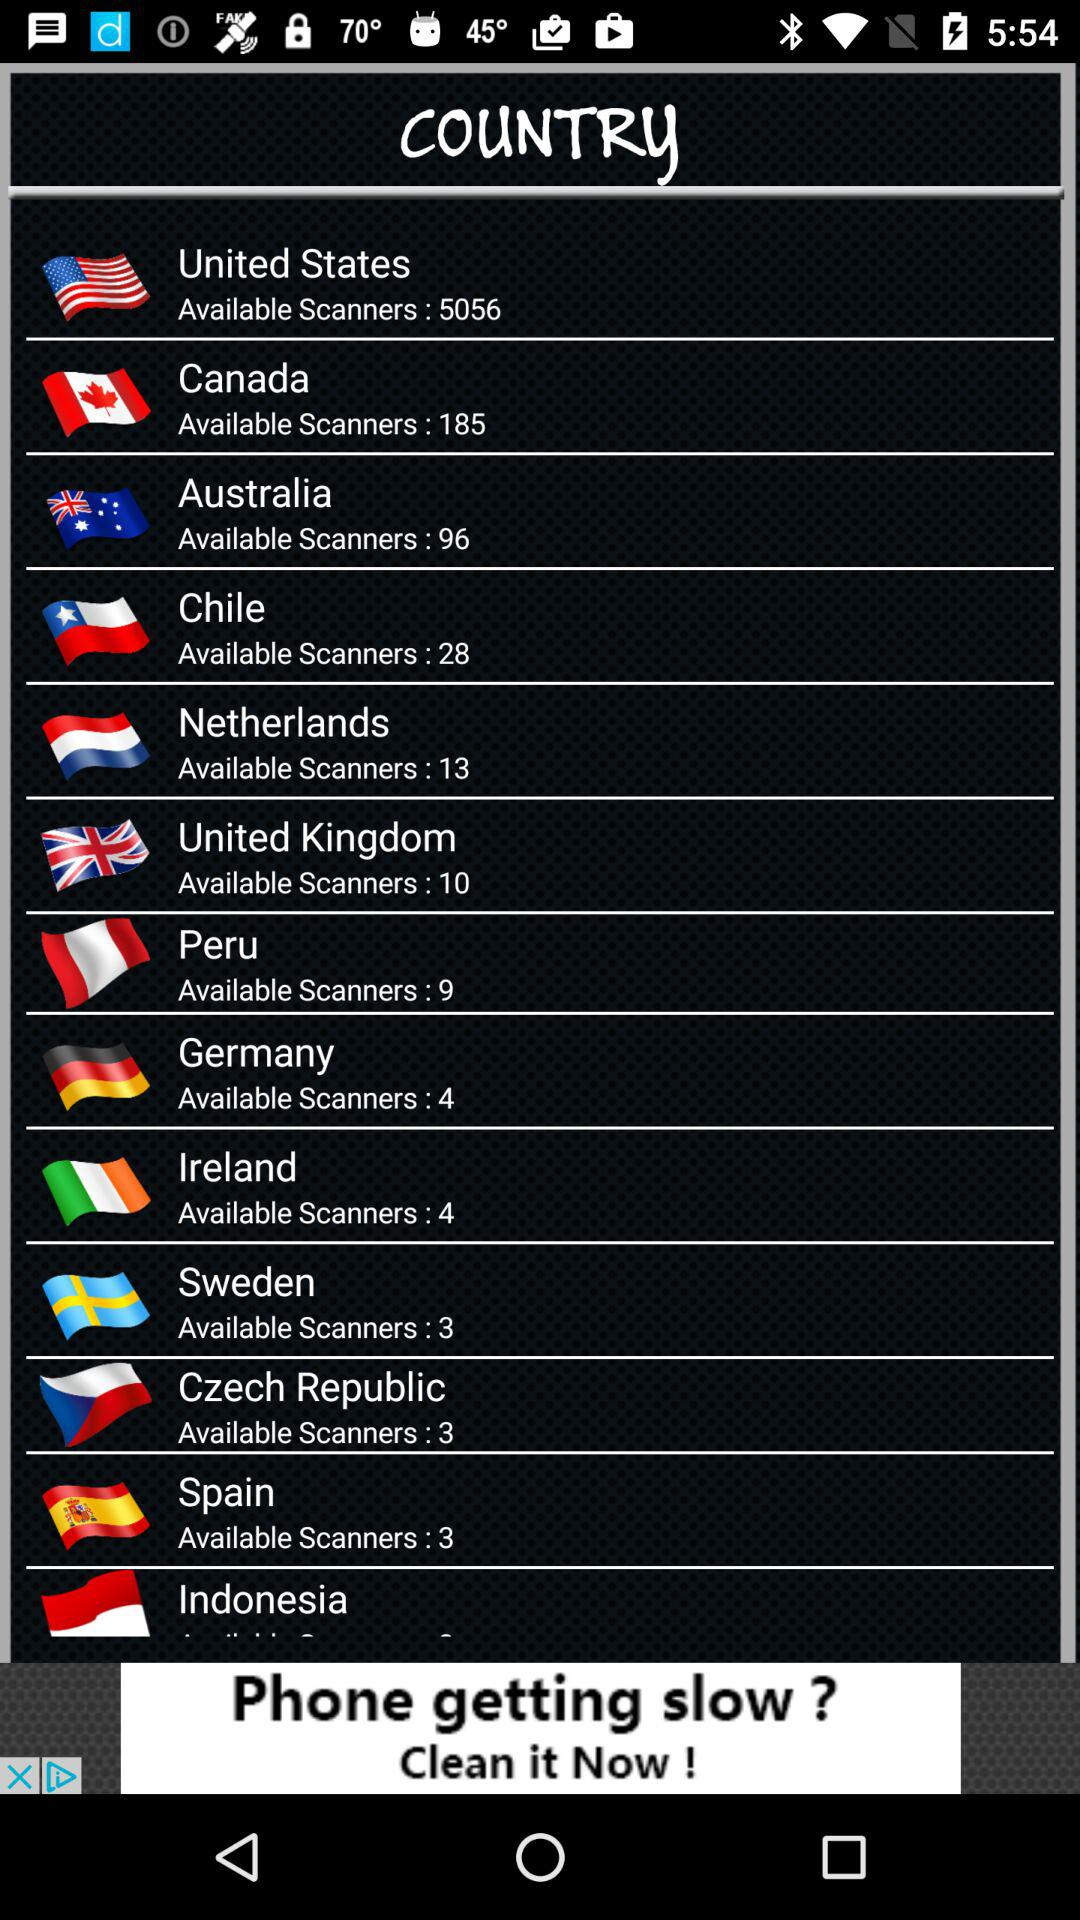Which country has the most scanners available?
Answer the question using a single word or phrase. United States 